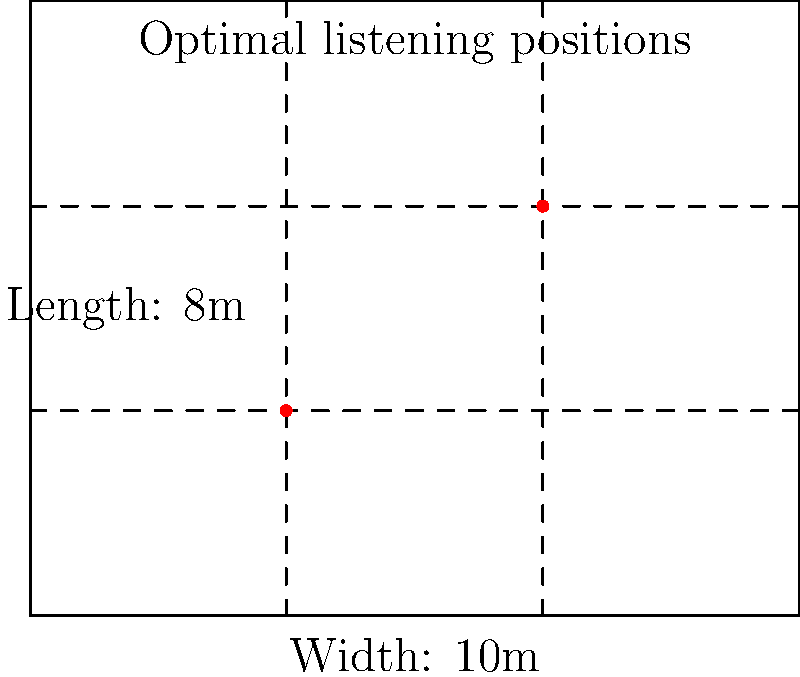As an audiophile setting up a listening room for your Frankie Goes to Hollywood collection, you want to determine the optimal listening positions based on standing wave patterns. Given a rectangular room with dimensions 10m x 8m, at which two points (in meters) should you place your listening chairs to minimize the effects of standing waves and achieve the best sound quality? To find the optimal listening positions, we need to follow these steps:

1) The best listening positions are typically at nodal points of standing waves, where pressure variations are minimal.

2) For a rectangular room, these points are often found at 1/3 and 2/3 of the room's dimensions.

3) For the width (10m):
   $1/3 \times 10m = 3.33m$
   $2/3 \times 10m = 6.67m$

4) For the length (8m):
   $1/3 \times 8m = 2.67m$
   $2/3 \times 8m = 5.33m$

5) Combining these coordinates gives us two optimal listening positions:
   $(3.33m, 2.67m)$ and $(6.67m, 5.33m)$

These positions should provide a balanced sound with minimal standing wave interference, allowing you to fully appreciate the nuances in Frankie Goes to Hollywood's music.
Answer: $(3.33m, 2.67m)$ and $(6.67m, 5.33m)$ 